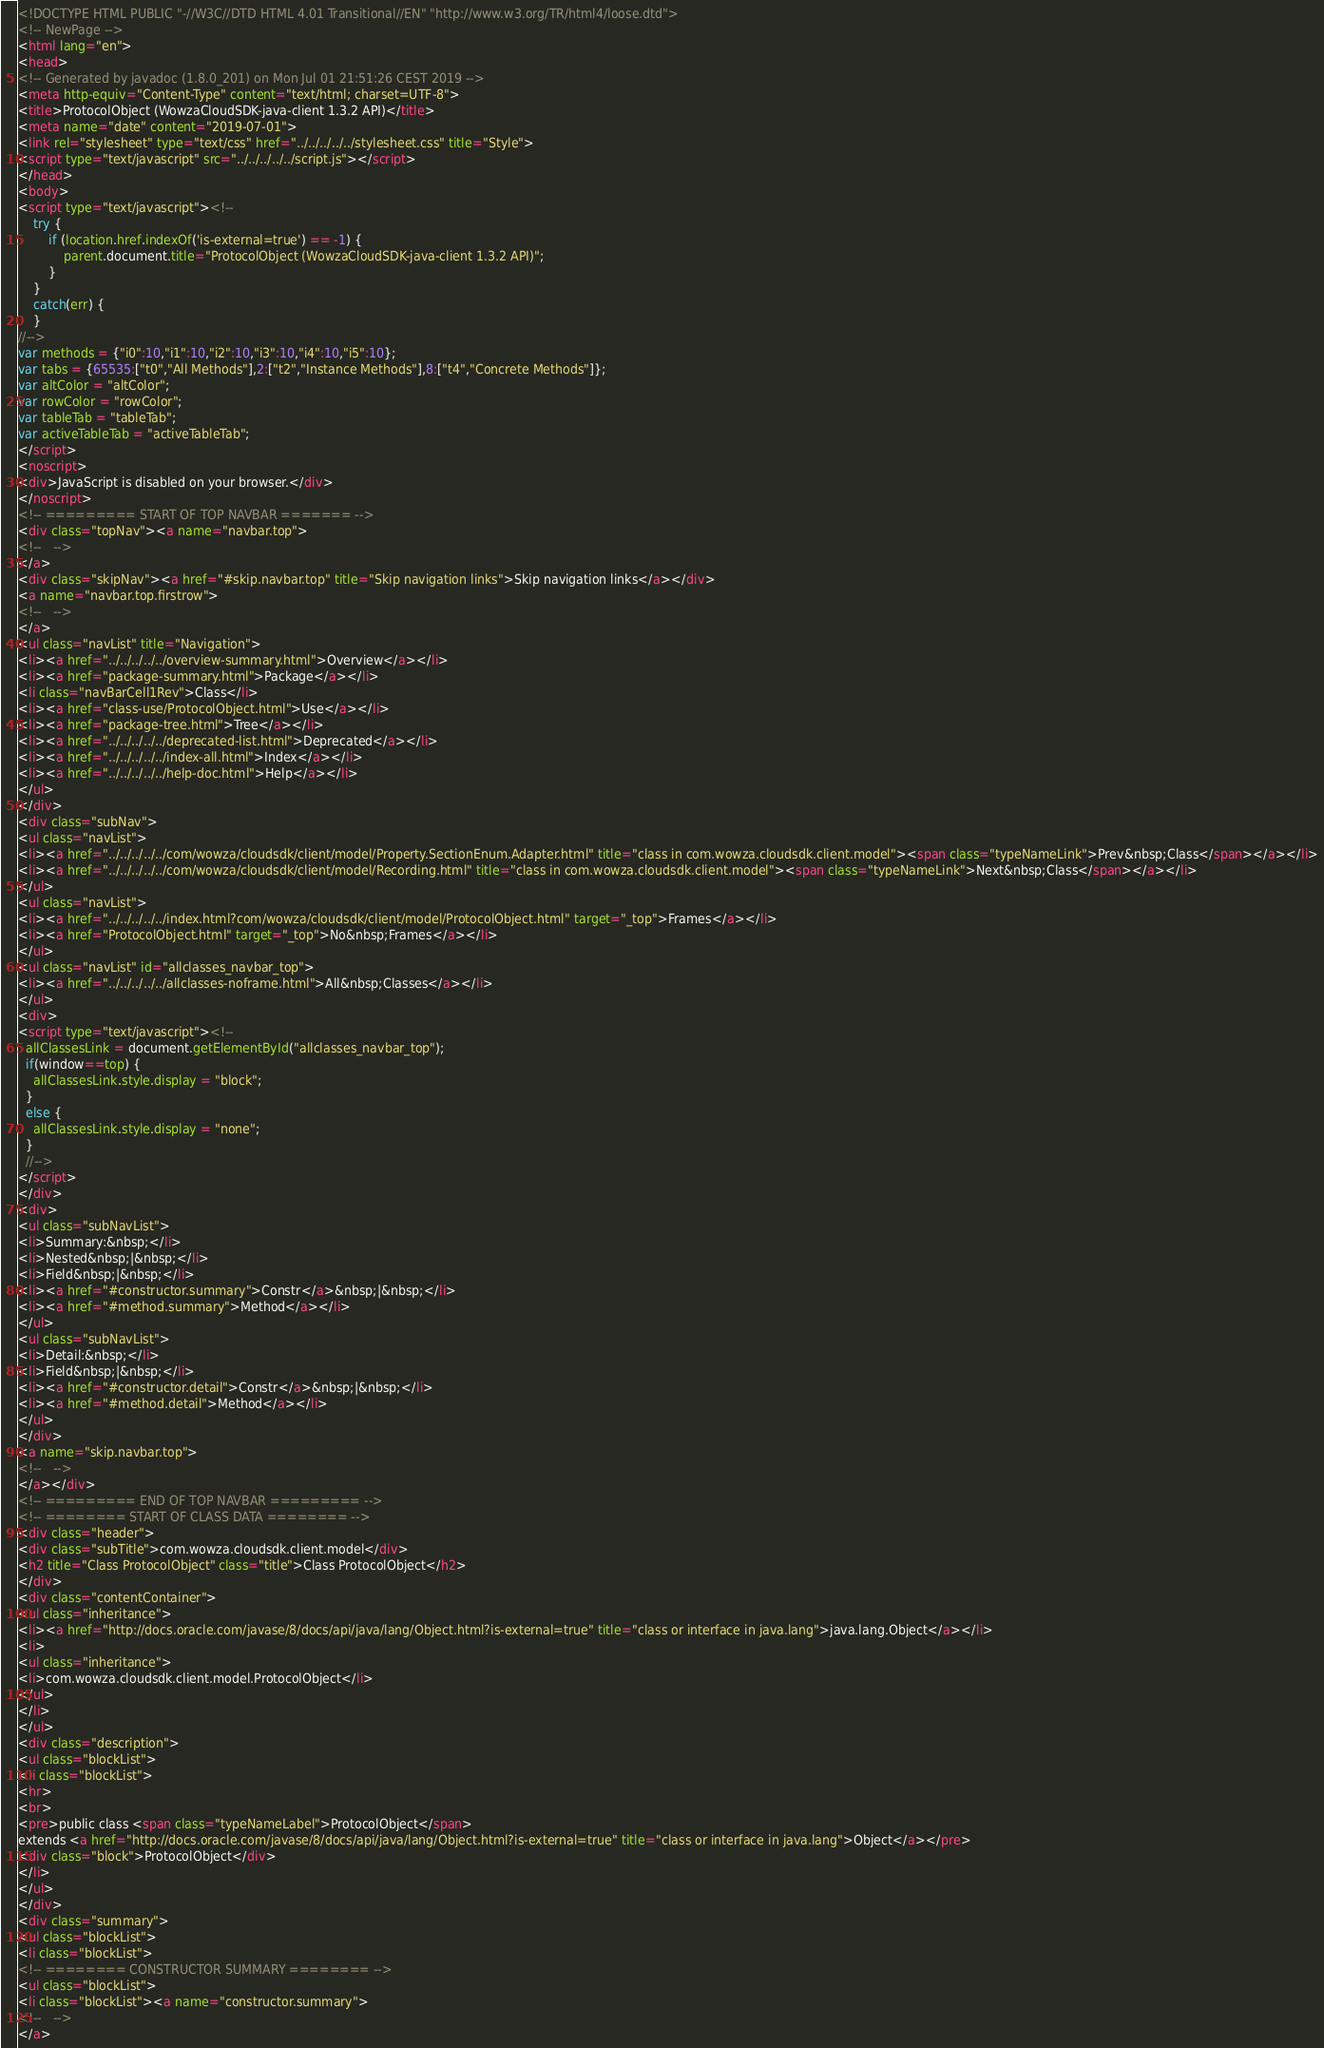Convert code to text. <code><loc_0><loc_0><loc_500><loc_500><_HTML_><!DOCTYPE HTML PUBLIC "-//W3C//DTD HTML 4.01 Transitional//EN" "http://www.w3.org/TR/html4/loose.dtd">
<!-- NewPage -->
<html lang="en">
<head>
<!-- Generated by javadoc (1.8.0_201) on Mon Jul 01 21:51:26 CEST 2019 -->
<meta http-equiv="Content-Type" content="text/html; charset=UTF-8">
<title>ProtocolObject (WowzaCloudSDK-java-client 1.3.2 API)</title>
<meta name="date" content="2019-07-01">
<link rel="stylesheet" type="text/css" href="../../../../../stylesheet.css" title="Style">
<script type="text/javascript" src="../../../../../script.js"></script>
</head>
<body>
<script type="text/javascript"><!--
    try {
        if (location.href.indexOf('is-external=true') == -1) {
            parent.document.title="ProtocolObject (WowzaCloudSDK-java-client 1.3.2 API)";
        }
    }
    catch(err) {
    }
//-->
var methods = {"i0":10,"i1":10,"i2":10,"i3":10,"i4":10,"i5":10};
var tabs = {65535:["t0","All Methods"],2:["t2","Instance Methods"],8:["t4","Concrete Methods"]};
var altColor = "altColor";
var rowColor = "rowColor";
var tableTab = "tableTab";
var activeTableTab = "activeTableTab";
</script>
<noscript>
<div>JavaScript is disabled on your browser.</div>
</noscript>
<!-- ========= START OF TOP NAVBAR ======= -->
<div class="topNav"><a name="navbar.top">
<!--   -->
</a>
<div class="skipNav"><a href="#skip.navbar.top" title="Skip navigation links">Skip navigation links</a></div>
<a name="navbar.top.firstrow">
<!--   -->
</a>
<ul class="navList" title="Navigation">
<li><a href="../../../../../overview-summary.html">Overview</a></li>
<li><a href="package-summary.html">Package</a></li>
<li class="navBarCell1Rev">Class</li>
<li><a href="class-use/ProtocolObject.html">Use</a></li>
<li><a href="package-tree.html">Tree</a></li>
<li><a href="../../../../../deprecated-list.html">Deprecated</a></li>
<li><a href="../../../../../index-all.html">Index</a></li>
<li><a href="../../../../../help-doc.html">Help</a></li>
</ul>
</div>
<div class="subNav">
<ul class="navList">
<li><a href="../../../../../com/wowza/cloudsdk/client/model/Property.SectionEnum.Adapter.html" title="class in com.wowza.cloudsdk.client.model"><span class="typeNameLink">Prev&nbsp;Class</span></a></li>
<li><a href="../../../../../com/wowza/cloudsdk/client/model/Recording.html" title="class in com.wowza.cloudsdk.client.model"><span class="typeNameLink">Next&nbsp;Class</span></a></li>
</ul>
<ul class="navList">
<li><a href="../../../../../index.html?com/wowza/cloudsdk/client/model/ProtocolObject.html" target="_top">Frames</a></li>
<li><a href="ProtocolObject.html" target="_top">No&nbsp;Frames</a></li>
</ul>
<ul class="navList" id="allclasses_navbar_top">
<li><a href="../../../../../allclasses-noframe.html">All&nbsp;Classes</a></li>
</ul>
<div>
<script type="text/javascript"><!--
  allClassesLink = document.getElementById("allclasses_navbar_top");
  if(window==top) {
    allClassesLink.style.display = "block";
  }
  else {
    allClassesLink.style.display = "none";
  }
  //-->
</script>
</div>
<div>
<ul class="subNavList">
<li>Summary:&nbsp;</li>
<li>Nested&nbsp;|&nbsp;</li>
<li>Field&nbsp;|&nbsp;</li>
<li><a href="#constructor.summary">Constr</a>&nbsp;|&nbsp;</li>
<li><a href="#method.summary">Method</a></li>
</ul>
<ul class="subNavList">
<li>Detail:&nbsp;</li>
<li>Field&nbsp;|&nbsp;</li>
<li><a href="#constructor.detail">Constr</a>&nbsp;|&nbsp;</li>
<li><a href="#method.detail">Method</a></li>
</ul>
</div>
<a name="skip.navbar.top">
<!--   -->
</a></div>
<!-- ========= END OF TOP NAVBAR ========= -->
<!-- ======== START OF CLASS DATA ======== -->
<div class="header">
<div class="subTitle">com.wowza.cloudsdk.client.model</div>
<h2 title="Class ProtocolObject" class="title">Class ProtocolObject</h2>
</div>
<div class="contentContainer">
<ul class="inheritance">
<li><a href="http://docs.oracle.com/javase/8/docs/api/java/lang/Object.html?is-external=true" title="class or interface in java.lang">java.lang.Object</a></li>
<li>
<ul class="inheritance">
<li>com.wowza.cloudsdk.client.model.ProtocolObject</li>
</ul>
</li>
</ul>
<div class="description">
<ul class="blockList">
<li class="blockList">
<hr>
<br>
<pre>public class <span class="typeNameLabel">ProtocolObject</span>
extends <a href="http://docs.oracle.com/javase/8/docs/api/java/lang/Object.html?is-external=true" title="class or interface in java.lang">Object</a></pre>
<div class="block">ProtocolObject</div>
</li>
</ul>
</div>
<div class="summary">
<ul class="blockList">
<li class="blockList">
<!-- ======== CONSTRUCTOR SUMMARY ======== -->
<ul class="blockList">
<li class="blockList"><a name="constructor.summary">
<!--   -->
</a></code> 